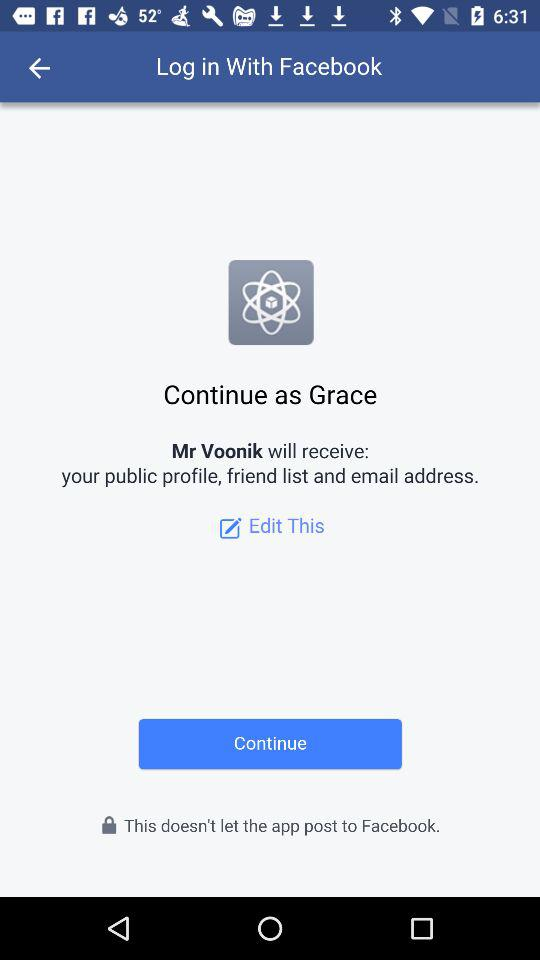What application is asking for permission? The application "Mr Voonik" is asking for permission. 